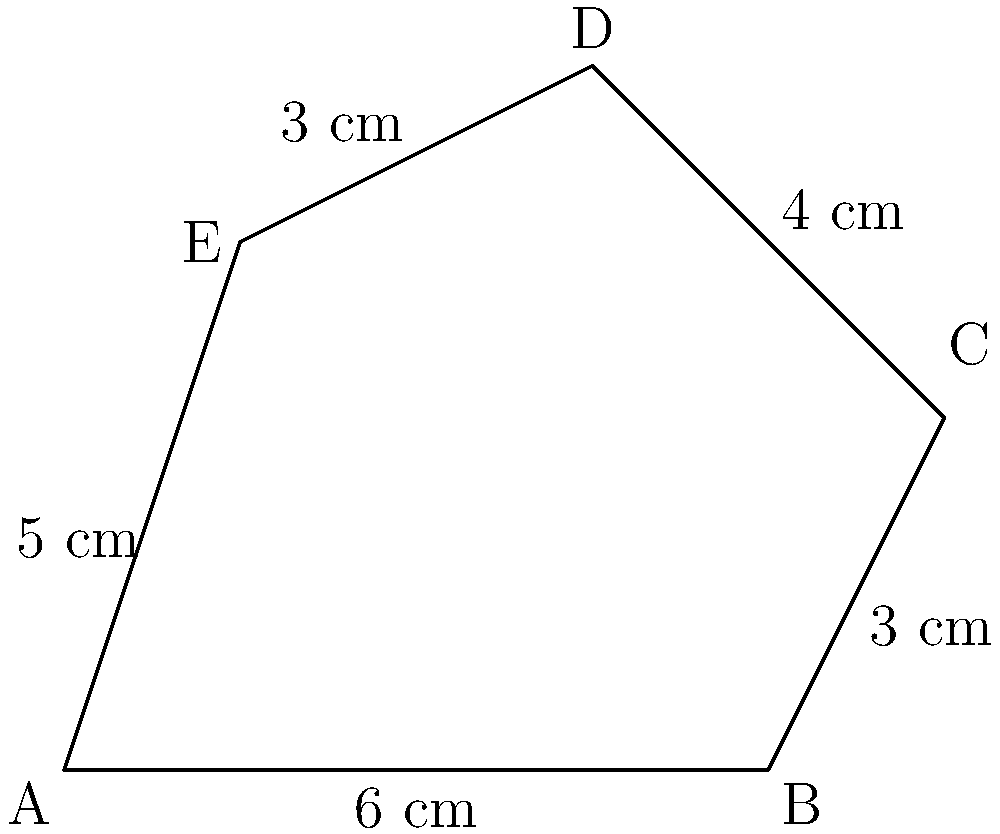Calculate the perimeter of the irregular pentagon ABCDE shown in the figure. All measurements are given in centimeters. To calculate the perimeter of an irregular polygon, we need to sum up the lengths of all its sides. Let's go through this step-by-step:

1) Identify the lengths of each side:
   AB = 6 cm
   BC = 3 cm
   CD = 4 cm
   DE = 3 cm
   EA = 5 cm

2) Add up all these lengths:
   Perimeter = AB + BC + CD + DE + EA
             = 6 + 3 + 4 + 3 + 5

3) Perform the addition:
   Perimeter = 21 cm

Therefore, the perimeter of the irregular pentagon ABCDE is 21 cm.
Answer: 21 cm 